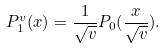<formula> <loc_0><loc_0><loc_500><loc_500>P _ { 1 } ^ { v } ( x ) = \frac { 1 } { \sqrt { v } } P _ { 0 } ( \frac { x } { \sqrt { v } } ) .</formula> 